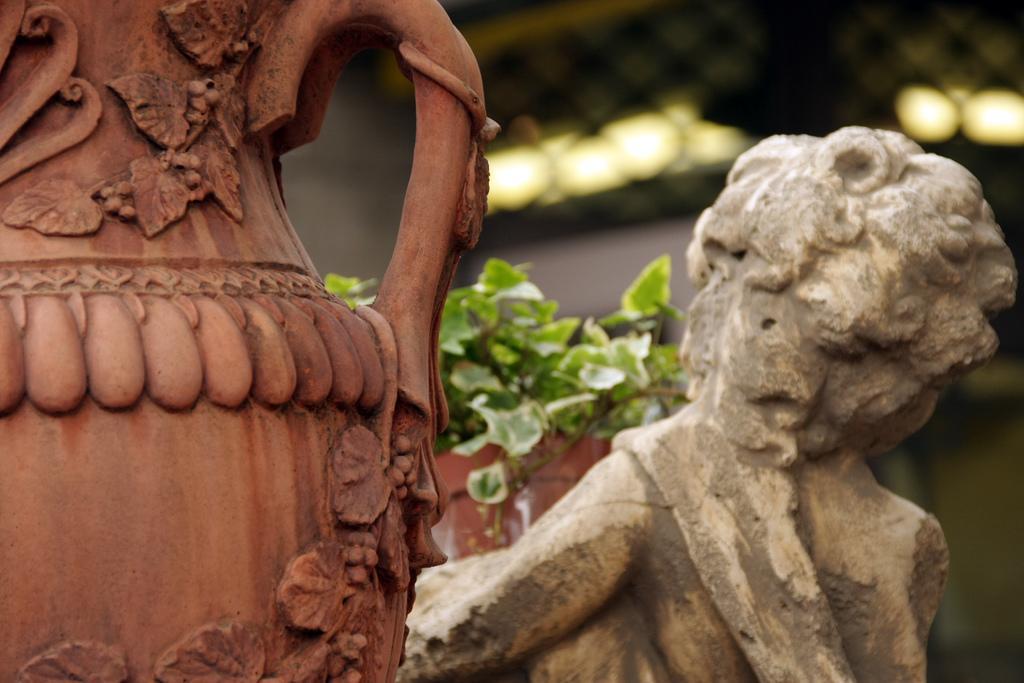Please provide a concise description of this image. Here, we can see some flower pots and there are some green color plants, in the background we can see some lights. 